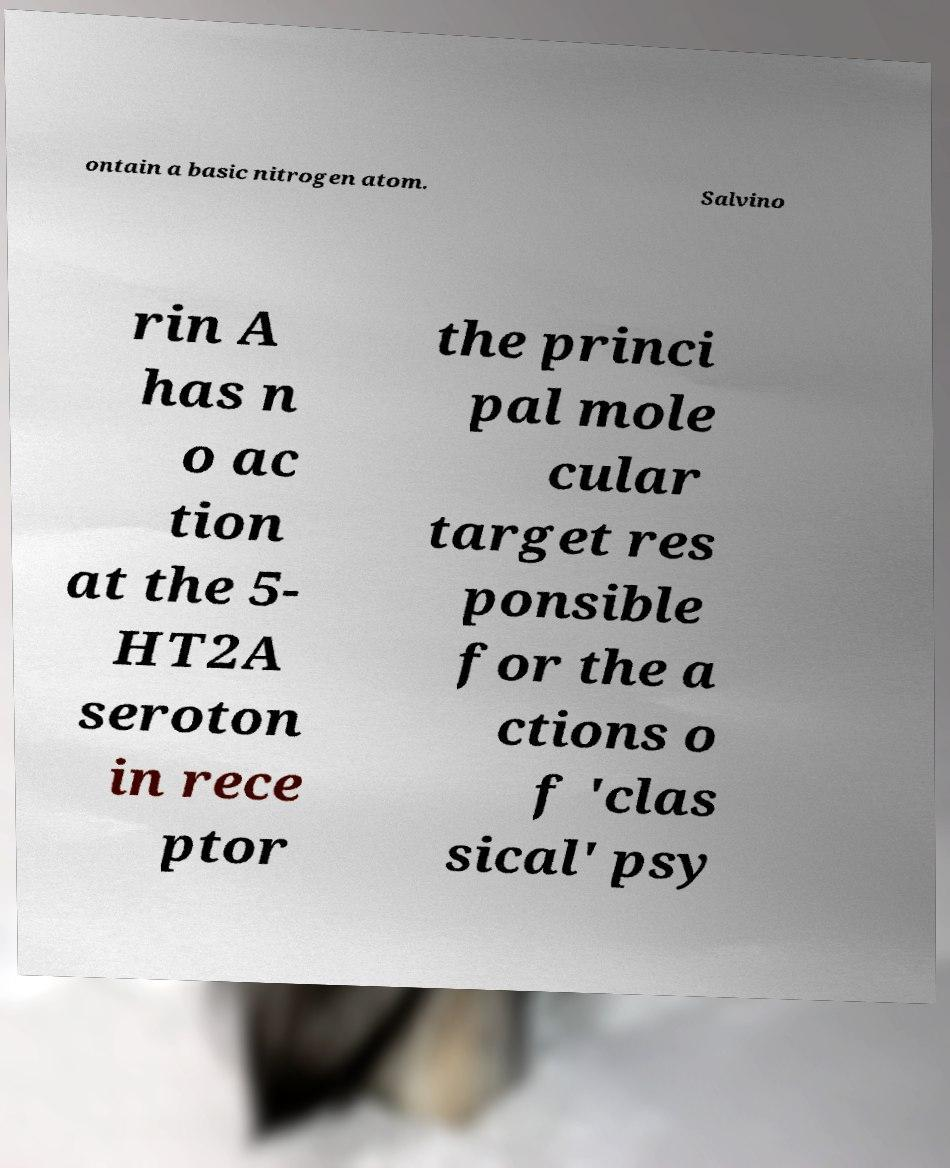What messages or text are displayed in this image? I need them in a readable, typed format. ontain a basic nitrogen atom. Salvino rin A has n o ac tion at the 5- HT2A seroton in rece ptor the princi pal mole cular target res ponsible for the a ctions o f 'clas sical' psy 